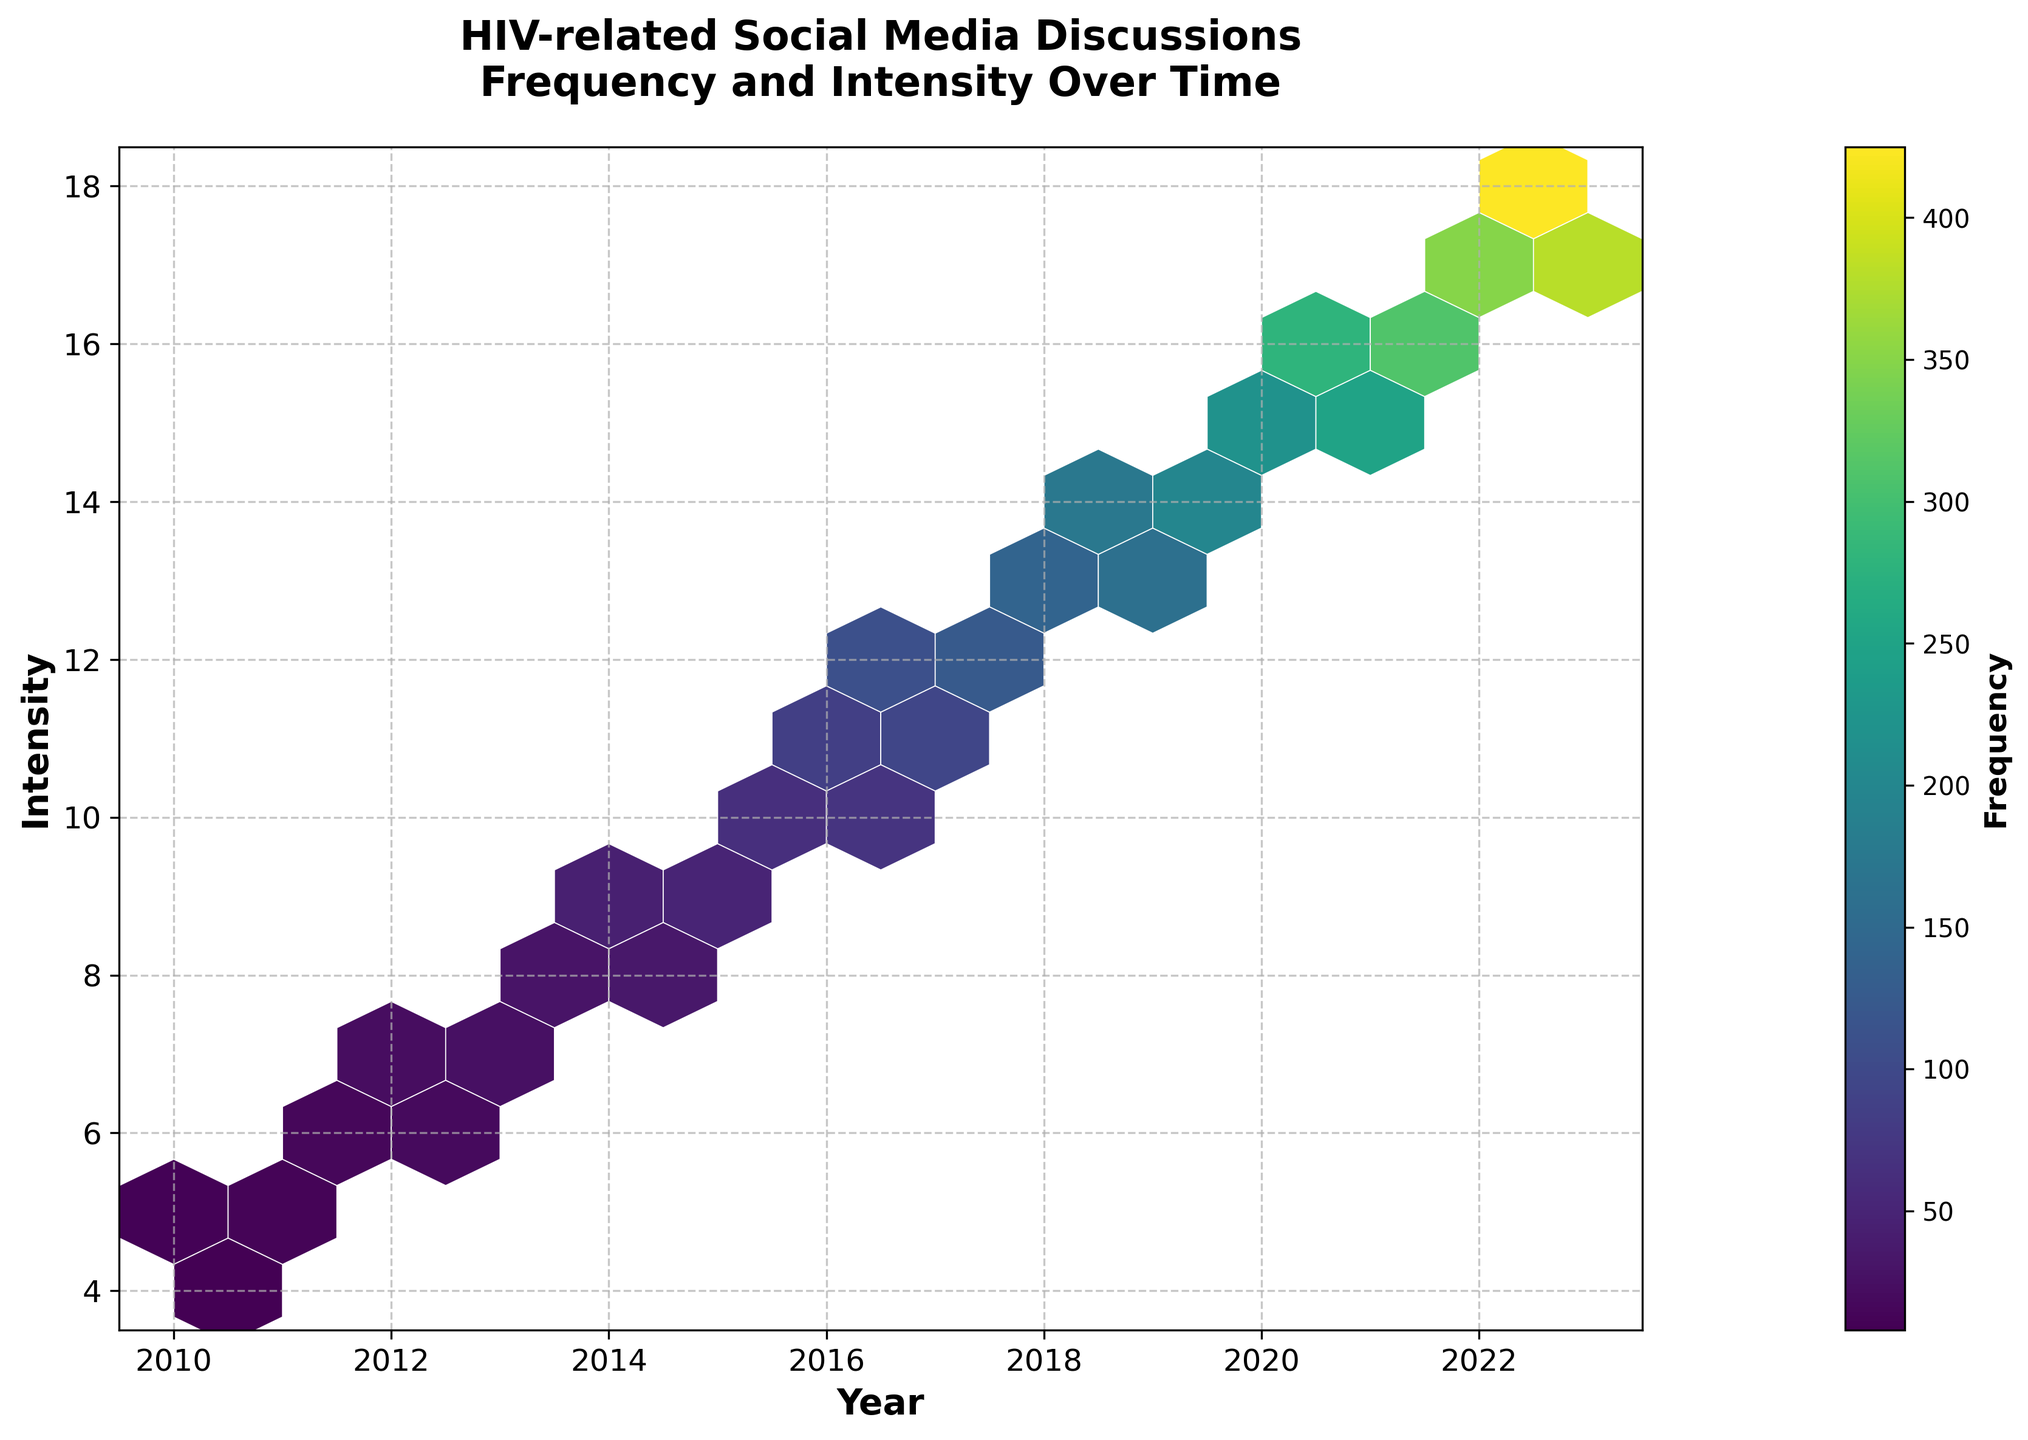What is the title of the figure? The title is located at the top of the figure in a larger, bold font.
Answer: HIV-related Social Media Discussions Frequency and Intensity Over Time Which axis represents the year? The x-axis (horizontal axis) represents the year, as indicated by the label "Year" below it.
Answer: x-axis Which color represents the highest frequency? The color at the higher end of the colorbar (usually the brightest or most intense color) represents the highest frequency. In this case, it's a bright yellow-green color found at the highest end of the color gradient.
Answer: Bright yellow-green What is the frequency range covered in the colorbar? The colorbar shows the range of frequency values represented in the figure, from the lowest to the highest frequency. The labeled values on the colorbar provide this information.
Answer: 8 to 425 What year had the highest frequency of HIV-related discussions? By observing the brightness/intensity of the hexagons and referring to the colorbar, the hexagon corresponding to the highest color is around the year 2023.
Answer: 2023 How does the intensity of discussions in 2020 compare to 2014? Look at the hexagons corresponding to the years 2020 and 2014 and compare their colors using the colorbar. 2020 shows a higher frequency (brighter color) compared to 2014.
Answer: Higher in 2020 Between 2011 and 2012, which year had a greater frequency of discussions at intensity level 6? Observe the hexagons for the years 2011 and 2012 at the intensity level 6. The color for 2012 is closer to the higher end of the colorbar (brighter), indicating a higher frequency.
Answer: 2012 What is the range of intensity values shown on the y-axis? The y-axis shows the range of intensity values, which is clearly labeled from the lowest to the highest value covered in the plot.
Answer: 4 to 18 Which year has more intense discussions, 2013 or 2015? Check the color intensity of the hexagons for the years 2013 and 2015. The hexagon color for 2015 is closer to the brighter end of the colorbar compared to 2013.
Answer: 2015 What is the average frequency of discussions for the years 2021 and 2022? Locate the hexagons for the years 2021 and 2022. Using the colorbar, the estimated frequencies are about 280 and 350, respectively. Average them: (280 + 350) / 2 = 315.
Answer: 315 